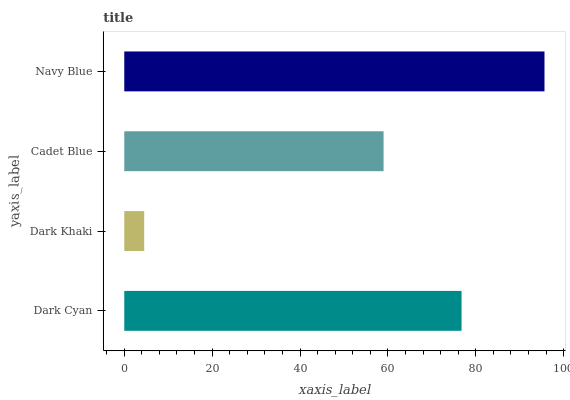Is Dark Khaki the minimum?
Answer yes or no. Yes. Is Navy Blue the maximum?
Answer yes or no. Yes. Is Cadet Blue the minimum?
Answer yes or no. No. Is Cadet Blue the maximum?
Answer yes or no. No. Is Cadet Blue greater than Dark Khaki?
Answer yes or no. Yes. Is Dark Khaki less than Cadet Blue?
Answer yes or no. Yes. Is Dark Khaki greater than Cadet Blue?
Answer yes or no. No. Is Cadet Blue less than Dark Khaki?
Answer yes or no. No. Is Dark Cyan the high median?
Answer yes or no. Yes. Is Cadet Blue the low median?
Answer yes or no. Yes. Is Navy Blue the high median?
Answer yes or no. No. Is Dark Khaki the low median?
Answer yes or no. No. 